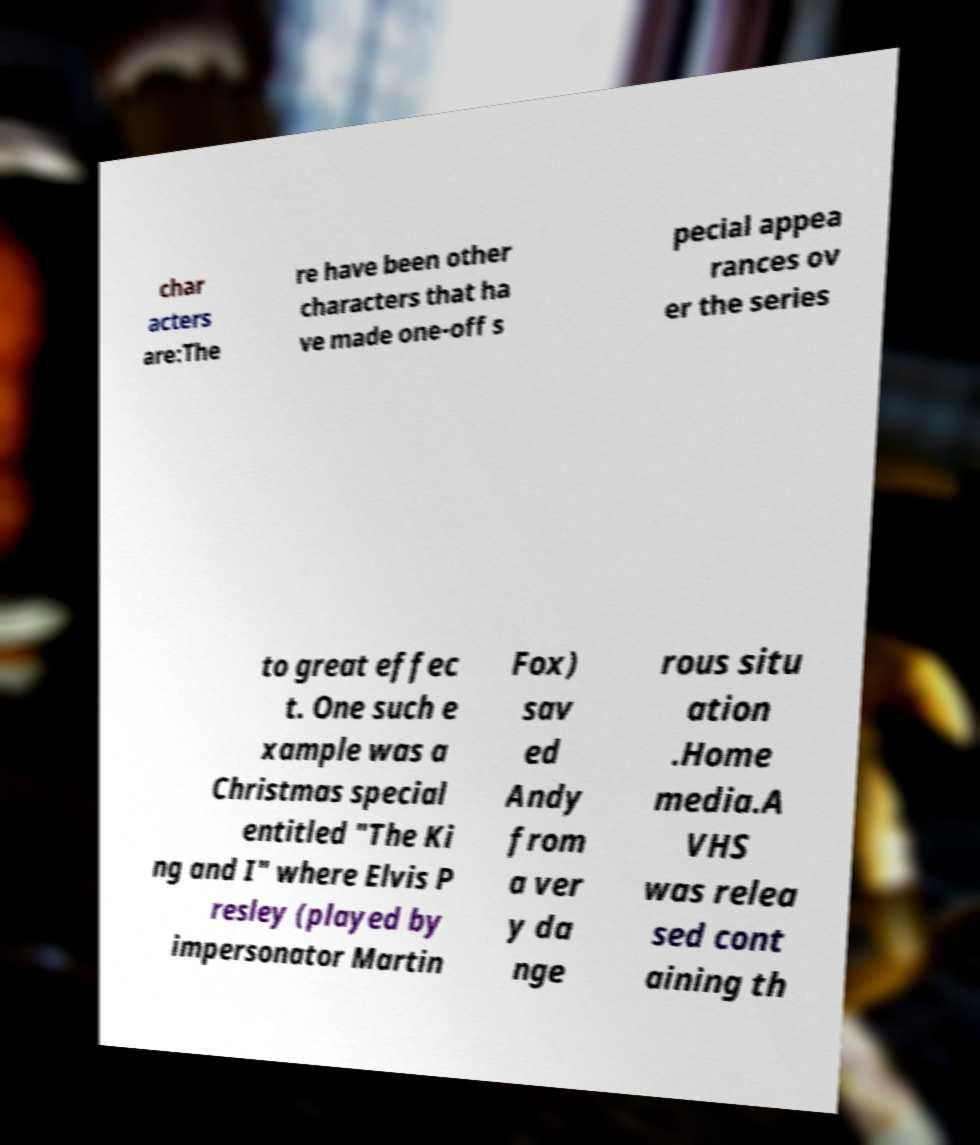I need the written content from this picture converted into text. Can you do that? char acters are:The re have been other characters that ha ve made one-off s pecial appea rances ov er the series to great effec t. One such e xample was a Christmas special entitled "The Ki ng and I" where Elvis P resley (played by impersonator Martin Fox) sav ed Andy from a ver y da nge rous situ ation .Home media.A VHS was relea sed cont aining th 